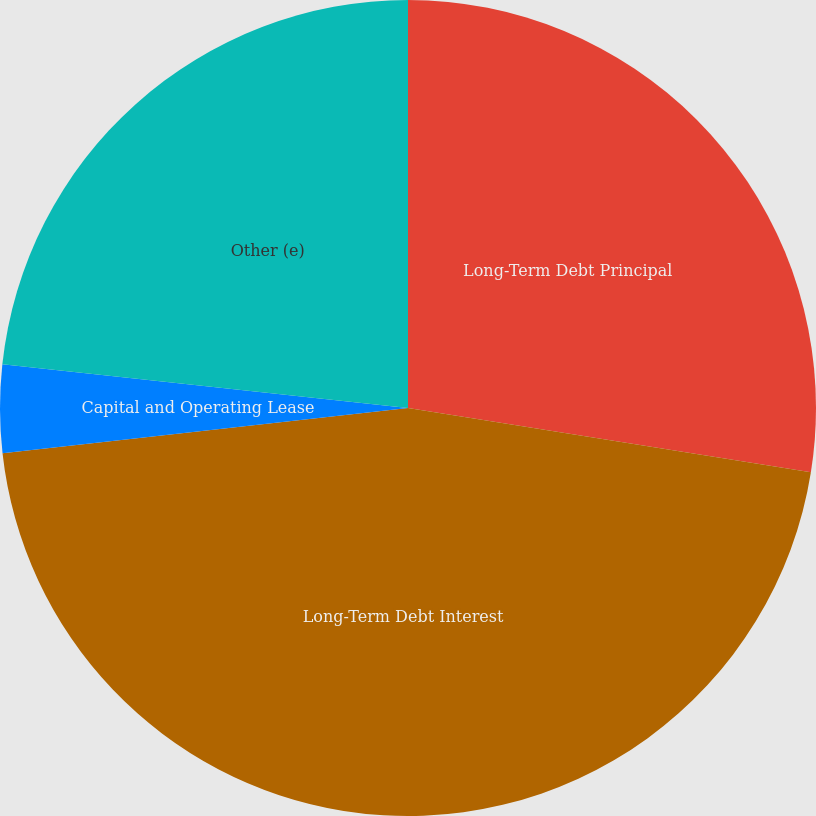<chart> <loc_0><loc_0><loc_500><loc_500><pie_chart><fcel>Long-Term Debt Principal<fcel>Long-Term Debt Interest<fcel>Capital and Operating Lease<fcel>Other (e)<nl><fcel>27.52%<fcel>45.71%<fcel>3.48%<fcel>23.29%<nl></chart> 